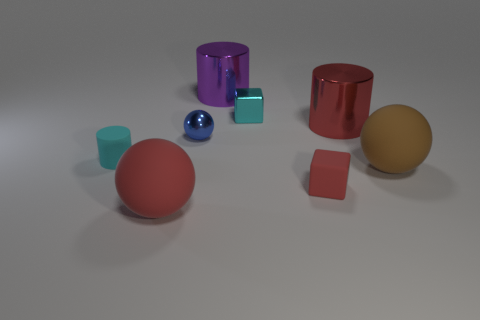Subtract all large red spheres. How many spheres are left? 2 Add 2 tiny cyan metal blocks. How many objects exist? 10 Subtract all cyan blocks. How many blocks are left? 1 Subtract 1 cylinders. How many cylinders are left? 2 Subtract all cyan cylinders. How many red spheres are left? 1 Add 8 tiny matte cylinders. How many tiny matte cylinders exist? 9 Subtract 1 red spheres. How many objects are left? 7 Subtract all spheres. How many objects are left? 5 Subtract all yellow blocks. Subtract all green balls. How many blocks are left? 2 Subtract all large blocks. Subtract all cyan objects. How many objects are left? 6 